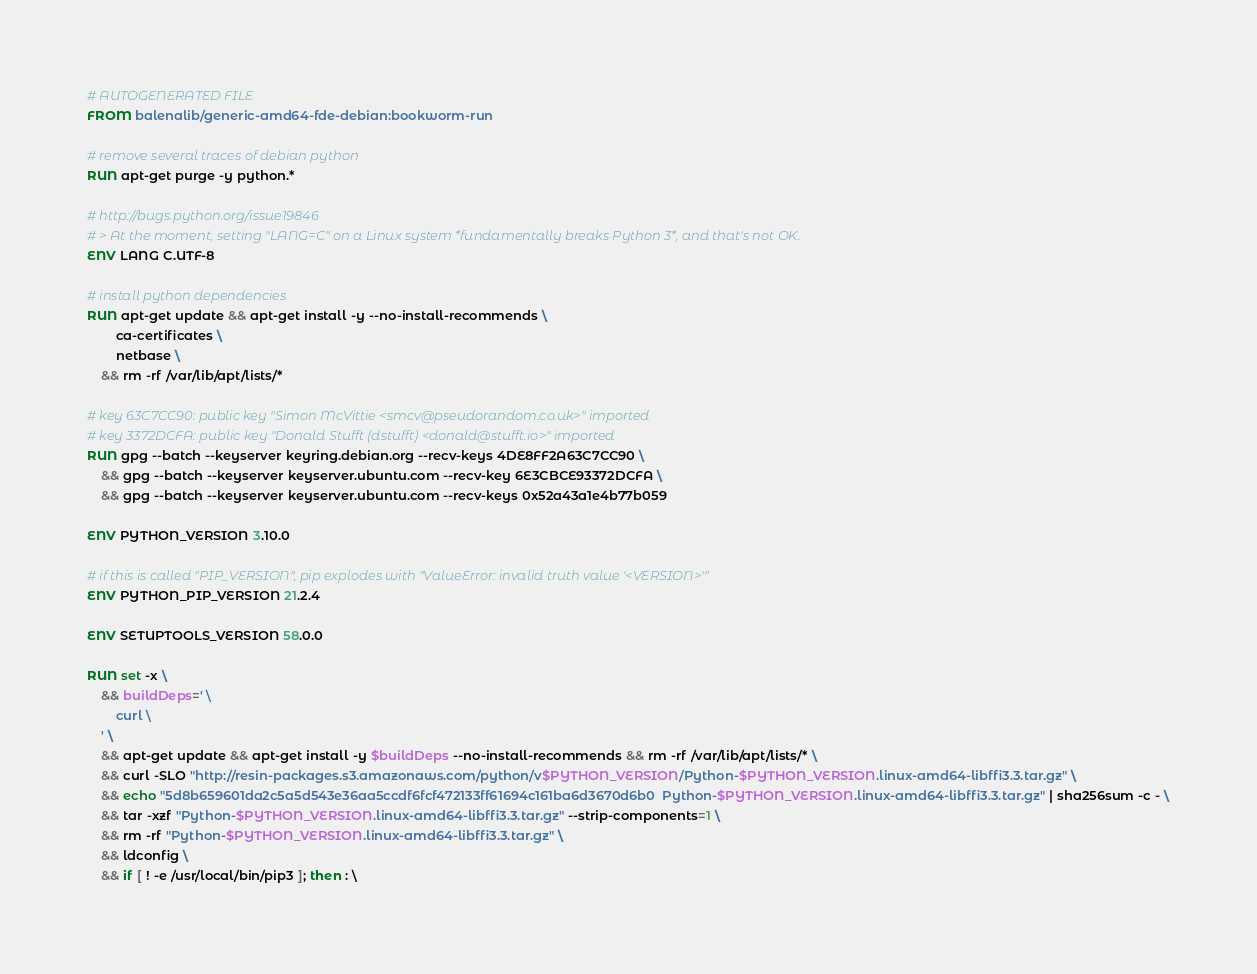<code> <loc_0><loc_0><loc_500><loc_500><_Dockerfile_># AUTOGENERATED FILE
FROM balenalib/generic-amd64-fde-debian:bookworm-run

# remove several traces of debian python
RUN apt-get purge -y python.*

# http://bugs.python.org/issue19846
# > At the moment, setting "LANG=C" on a Linux system *fundamentally breaks Python 3*, and that's not OK.
ENV LANG C.UTF-8

# install python dependencies
RUN apt-get update && apt-get install -y --no-install-recommends \
		ca-certificates \
		netbase \
	&& rm -rf /var/lib/apt/lists/*

# key 63C7CC90: public key "Simon McVittie <smcv@pseudorandom.co.uk>" imported
# key 3372DCFA: public key "Donald Stufft (dstufft) <donald@stufft.io>" imported
RUN gpg --batch --keyserver keyring.debian.org --recv-keys 4DE8FF2A63C7CC90 \
	&& gpg --batch --keyserver keyserver.ubuntu.com --recv-key 6E3CBCE93372DCFA \
	&& gpg --batch --keyserver keyserver.ubuntu.com --recv-keys 0x52a43a1e4b77b059

ENV PYTHON_VERSION 3.10.0

# if this is called "PIP_VERSION", pip explodes with "ValueError: invalid truth value '<VERSION>'"
ENV PYTHON_PIP_VERSION 21.2.4

ENV SETUPTOOLS_VERSION 58.0.0

RUN set -x \
	&& buildDeps=' \
		curl \
	' \
	&& apt-get update && apt-get install -y $buildDeps --no-install-recommends && rm -rf /var/lib/apt/lists/* \
	&& curl -SLO "http://resin-packages.s3.amazonaws.com/python/v$PYTHON_VERSION/Python-$PYTHON_VERSION.linux-amd64-libffi3.3.tar.gz" \
	&& echo "5d8b659601da2c5a5d543e36aa5ccdf6fcf472133ff61694c161ba6d3670d6b0  Python-$PYTHON_VERSION.linux-amd64-libffi3.3.tar.gz" | sha256sum -c - \
	&& tar -xzf "Python-$PYTHON_VERSION.linux-amd64-libffi3.3.tar.gz" --strip-components=1 \
	&& rm -rf "Python-$PYTHON_VERSION.linux-amd64-libffi3.3.tar.gz" \
	&& ldconfig \
	&& if [ ! -e /usr/local/bin/pip3 ]; then : \</code> 